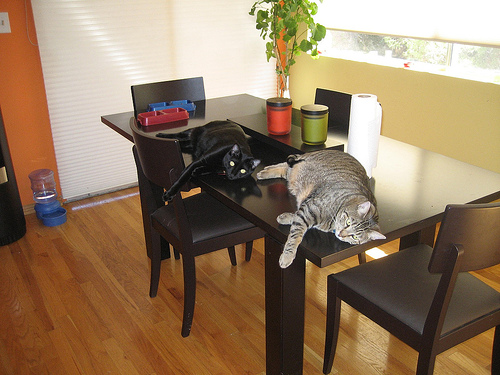<image>
Is there a cat on the table? Yes. Looking at the image, I can see the cat is positioned on top of the table, with the table providing support. 